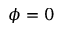<formula> <loc_0><loc_0><loc_500><loc_500>\phi = 0</formula> 